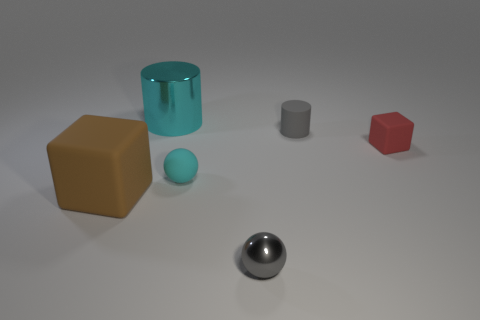Subtract all cylinders. How many objects are left? 4 Add 2 tiny yellow cubes. How many objects exist? 8 Add 6 large cyan metallic objects. How many large cyan metallic objects exist? 7 Subtract 0 blue cylinders. How many objects are left? 6 Subtract 1 cylinders. How many cylinders are left? 1 Subtract all purple cubes. Subtract all purple cylinders. How many cubes are left? 2 Subtract all gray blocks. How many gray spheres are left? 1 Subtract all red rubber balls. Subtract all big brown matte blocks. How many objects are left? 5 Add 1 gray objects. How many gray objects are left? 3 